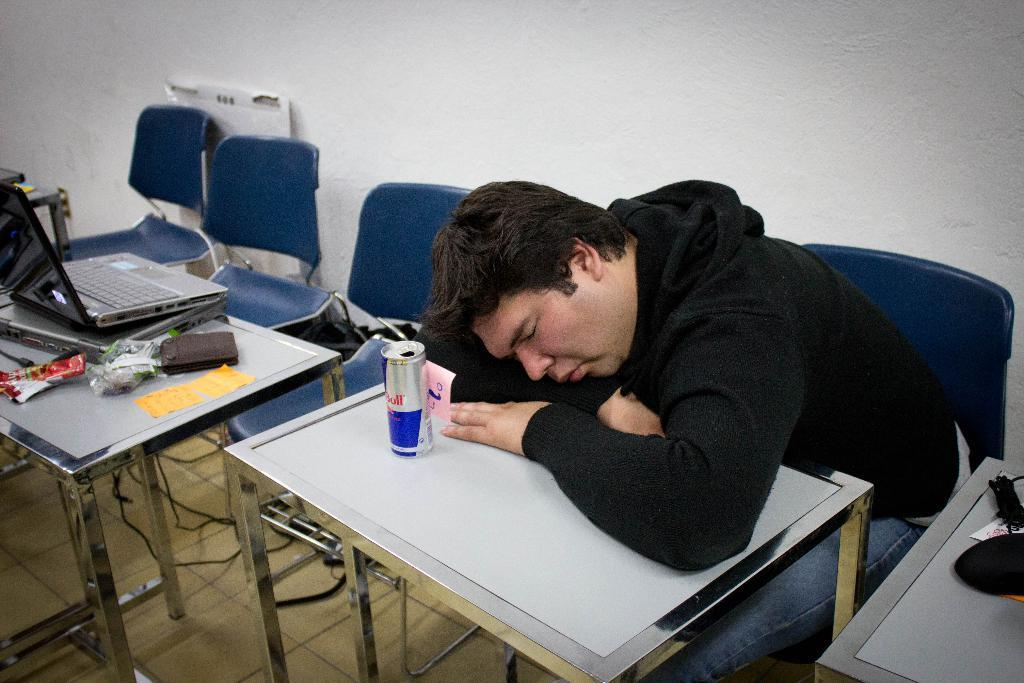What is the person in the image doing? The person is sitting on a chair. Is the person engaged in any activity in the image? Yes, the person is sleeping on a table. What is on the tin in the image? There is a tin with objects on it. What can be seen in the background of the image? There is a wall visible in the image. What color is the ink on the daughter's hand in the image? There is no daughter or ink present in the image. Where is the middle of the image located? The concept of "middle" in an image is relative and depends on the viewer's perspective, so it cannot be definitively determined from the provided facts. 